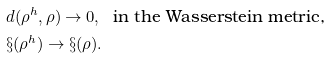<formula> <loc_0><loc_0><loc_500><loc_500>& d ( \rho ^ { h } , \rho ) \to 0 , \ \text { in the Wasserstein metric,} \\ & \S ( \rho ^ { h } ) \to \S ( \rho ) .</formula> 